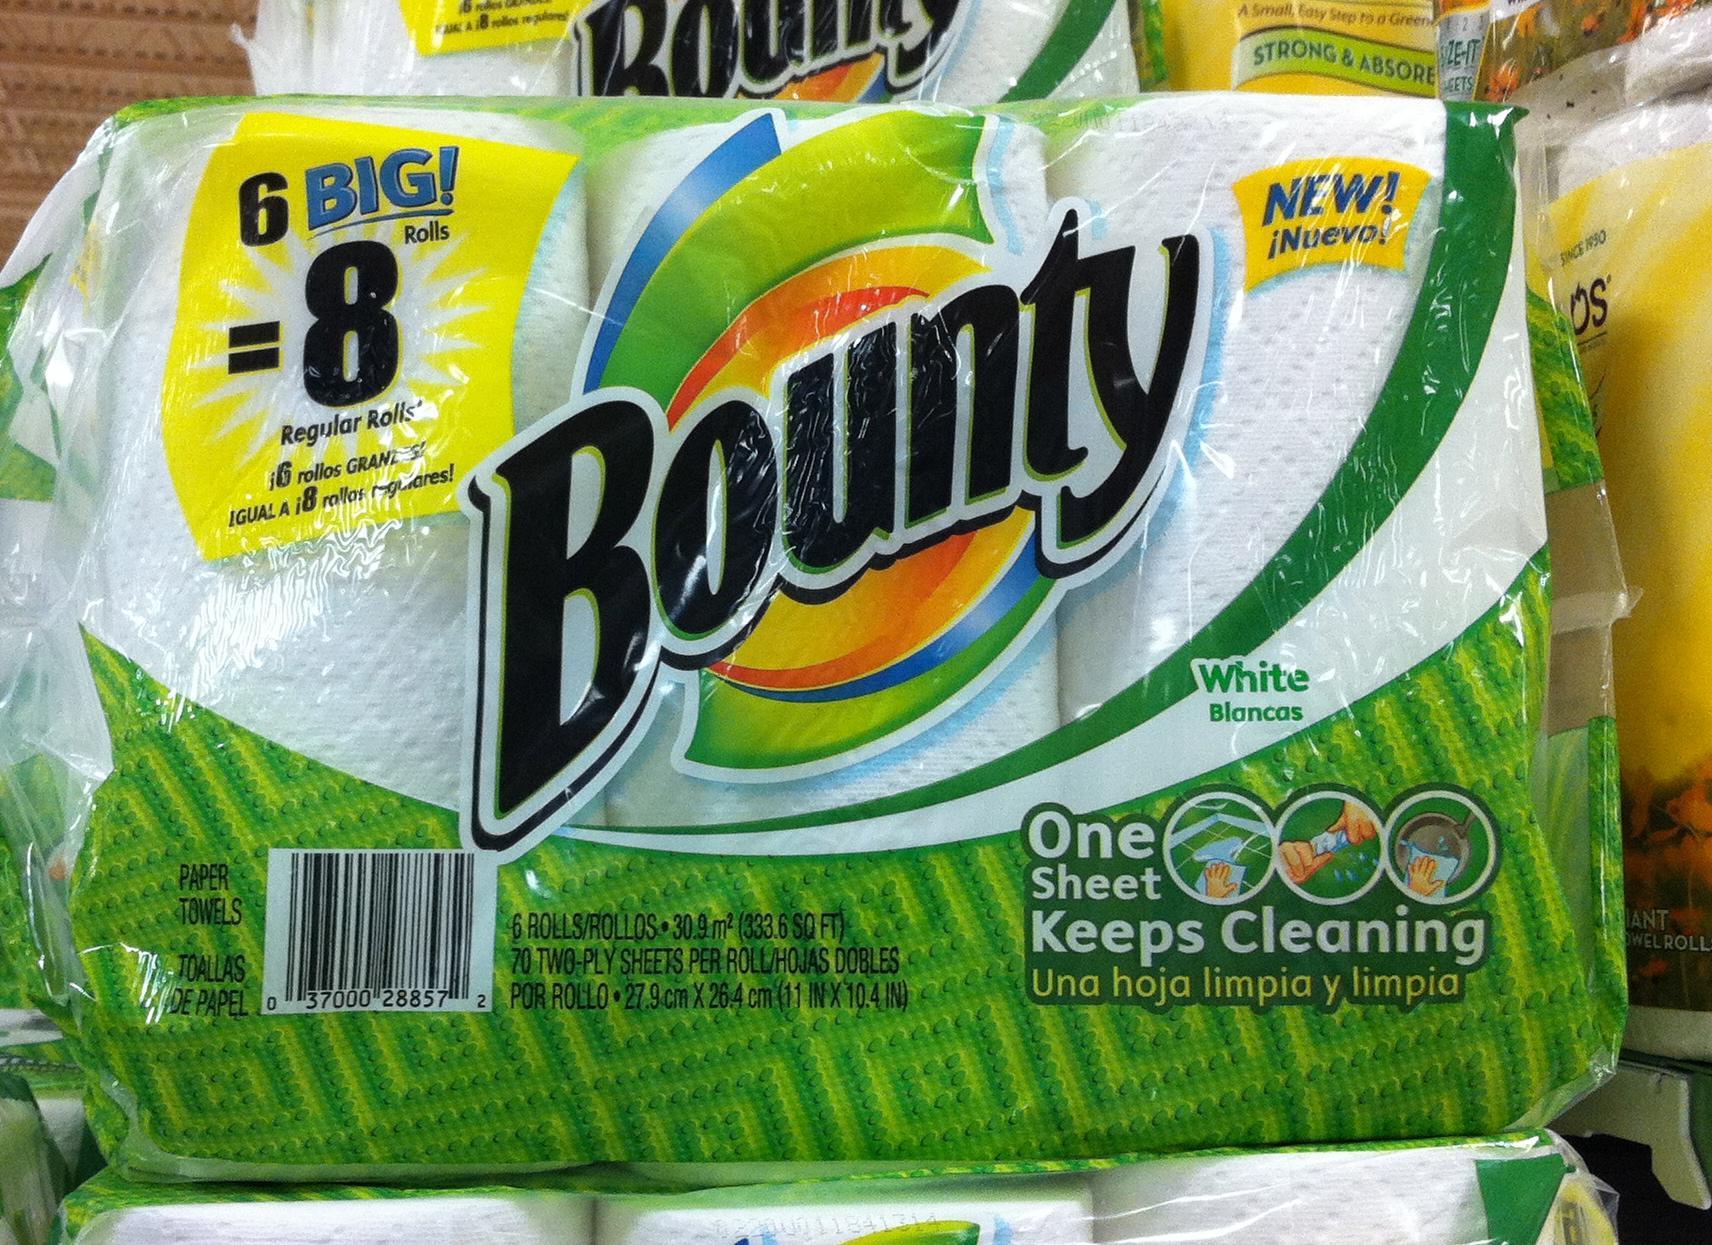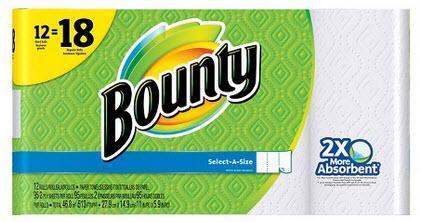The first image is the image on the left, the second image is the image on the right. For the images shown, is this caption "In one of the images there is a single rectangular multi-pack of paper towels." true? Answer yes or no. Yes. The first image is the image on the left, the second image is the image on the right. For the images displayed, is the sentence "Right image shows a pack of paper towels on a store shelf with pegboard and a price sign visible." factually correct? Answer yes or no. No. 